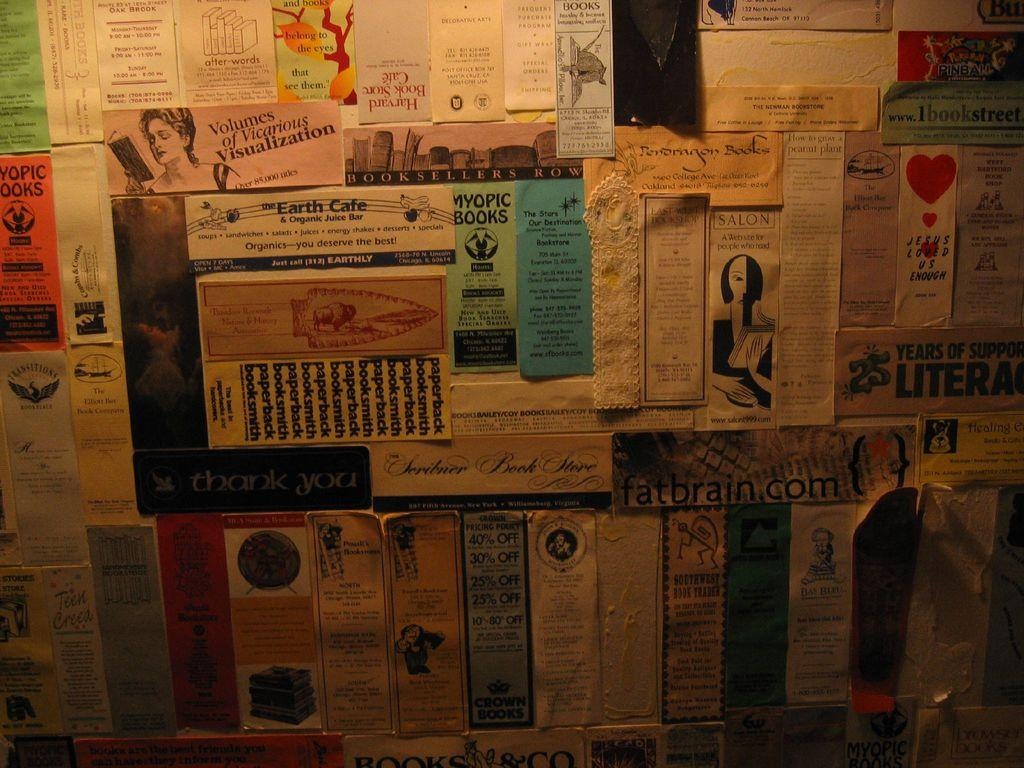Provide a one-sentence caption for the provided image. Wall full of many posters including one that says Myopic Books. 